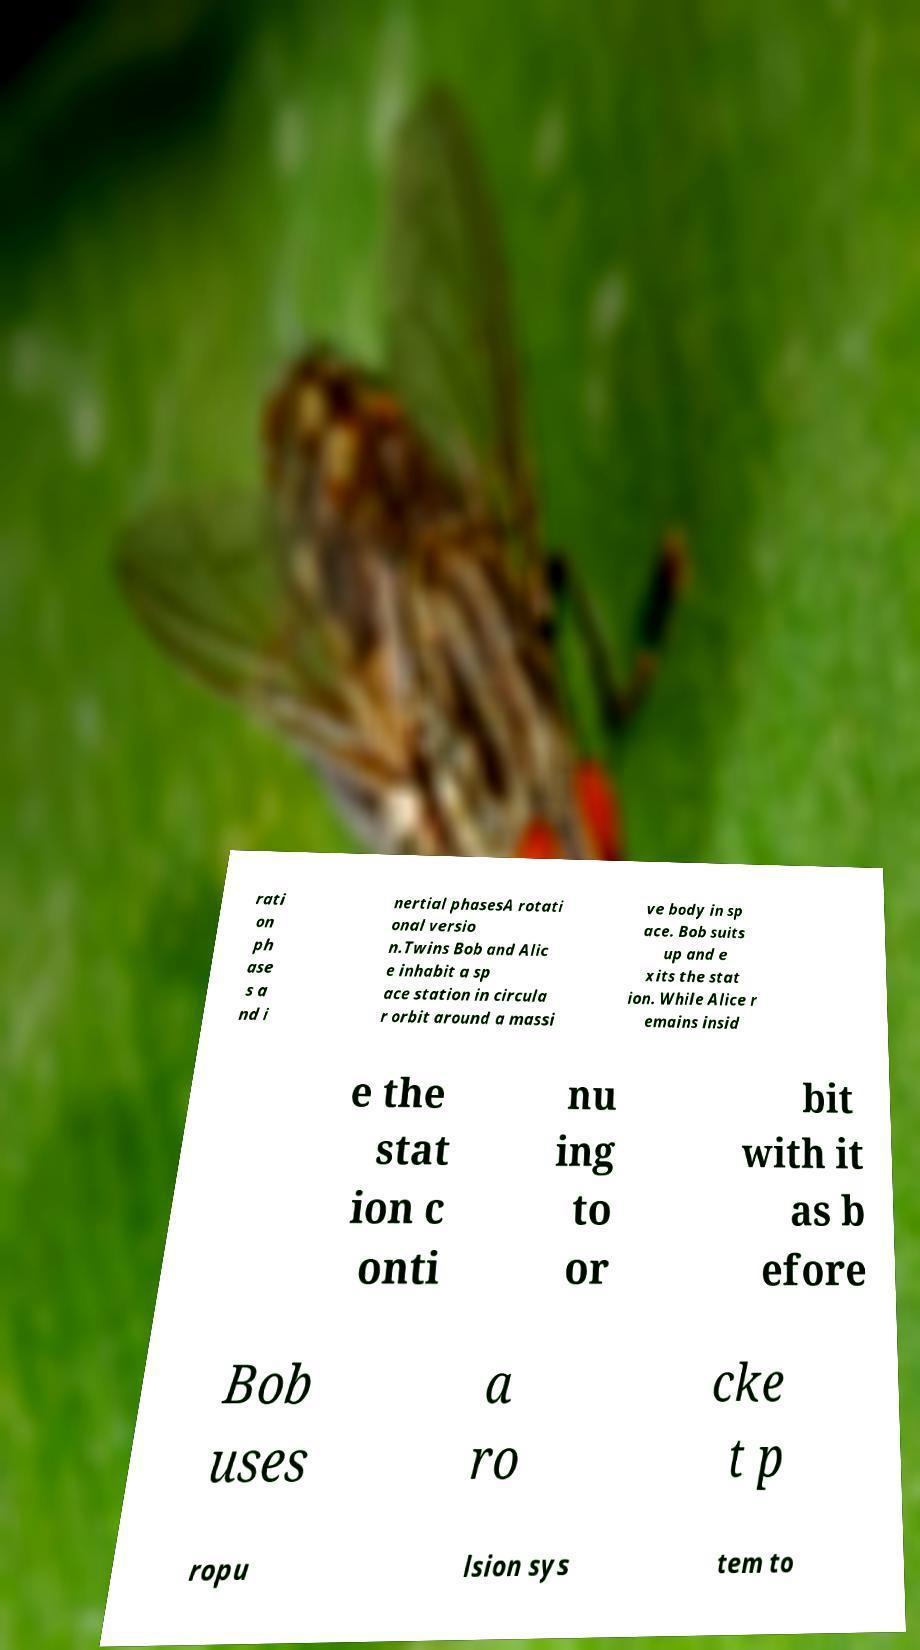Could you assist in decoding the text presented in this image and type it out clearly? rati on ph ase s a nd i nertial phasesA rotati onal versio n.Twins Bob and Alic e inhabit a sp ace station in circula r orbit around a massi ve body in sp ace. Bob suits up and e xits the stat ion. While Alice r emains insid e the stat ion c onti nu ing to or bit with it as b efore Bob uses a ro cke t p ropu lsion sys tem to 